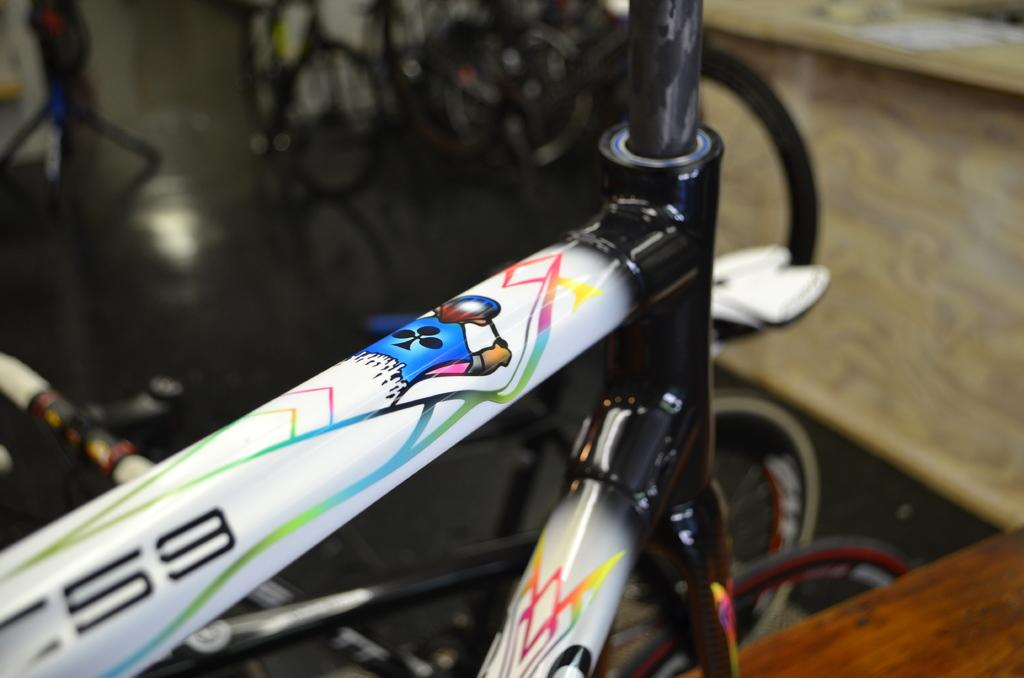What part of a bicycle is the main focus of the image? The image shows the top tube of a bicycle. Can you describe the surrounding environment in the image? There are bicycles visible in the background of the image. What song is playing in the background of the image? There is no information about any song playing in the image, as it only shows a bicycle top tube and other bicycles in the background. 